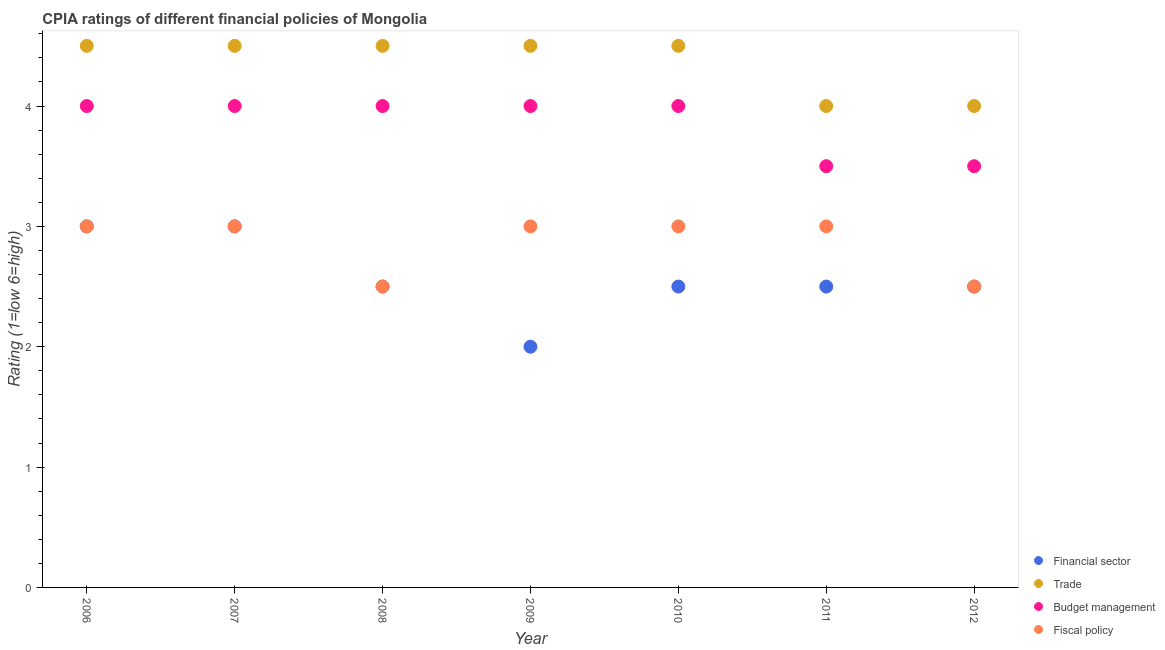Is the number of dotlines equal to the number of legend labels?
Your answer should be compact. Yes. Across all years, what is the maximum cpia rating of trade?
Your answer should be very brief. 4.5. In which year was the cpia rating of trade minimum?
Ensure brevity in your answer.  2011. What is the difference between the cpia rating of budget management in 2007 and that in 2011?
Offer a terse response. 0.5. What is the difference between the cpia rating of fiscal policy in 2006 and the cpia rating of trade in 2009?
Keep it short and to the point. -1.5. What is the average cpia rating of financial sector per year?
Your answer should be compact. 2.57. What is the ratio of the cpia rating of trade in 2007 to that in 2011?
Your answer should be compact. 1.12. In how many years, is the cpia rating of fiscal policy greater than the average cpia rating of fiscal policy taken over all years?
Your answer should be very brief. 5. Is the sum of the cpia rating of budget management in 2009 and 2010 greater than the maximum cpia rating of trade across all years?
Ensure brevity in your answer.  Yes. Is it the case that in every year, the sum of the cpia rating of budget management and cpia rating of financial sector is greater than the sum of cpia rating of trade and cpia rating of fiscal policy?
Offer a very short reply. No. Is it the case that in every year, the sum of the cpia rating of financial sector and cpia rating of trade is greater than the cpia rating of budget management?
Offer a terse response. Yes. Does the cpia rating of trade monotonically increase over the years?
Your answer should be compact. No. Is the cpia rating of budget management strictly greater than the cpia rating of financial sector over the years?
Ensure brevity in your answer.  Yes. Is the cpia rating of trade strictly less than the cpia rating of budget management over the years?
Your answer should be very brief. No. Does the graph contain any zero values?
Keep it short and to the point. No. Does the graph contain grids?
Keep it short and to the point. No. How many legend labels are there?
Offer a very short reply. 4. What is the title of the graph?
Your response must be concise. CPIA ratings of different financial policies of Mongolia. What is the label or title of the X-axis?
Your answer should be very brief. Year. What is the label or title of the Y-axis?
Provide a succinct answer. Rating (1=low 6=high). What is the Rating (1=low 6=high) in Trade in 2006?
Provide a short and direct response. 4.5. What is the Rating (1=low 6=high) of Budget management in 2006?
Offer a terse response. 4. What is the Rating (1=low 6=high) in Budget management in 2007?
Make the answer very short. 4. What is the Rating (1=low 6=high) of Budget management in 2008?
Offer a terse response. 4. What is the Rating (1=low 6=high) in Fiscal policy in 2008?
Your response must be concise. 2.5. What is the Rating (1=low 6=high) of Financial sector in 2009?
Your answer should be very brief. 2. What is the Rating (1=low 6=high) in Trade in 2010?
Your answer should be very brief. 4.5. What is the Rating (1=low 6=high) of Budget management in 2010?
Provide a succinct answer. 4. What is the Rating (1=low 6=high) in Fiscal policy in 2010?
Your response must be concise. 3. What is the Rating (1=low 6=high) of Financial sector in 2011?
Offer a terse response. 2.5. What is the Rating (1=low 6=high) in Budget management in 2012?
Offer a very short reply. 3.5. Across all years, what is the maximum Rating (1=low 6=high) of Financial sector?
Provide a short and direct response. 3. Across all years, what is the maximum Rating (1=low 6=high) in Trade?
Your answer should be compact. 4.5. Across all years, what is the maximum Rating (1=low 6=high) in Budget management?
Your answer should be very brief. 4. Across all years, what is the maximum Rating (1=low 6=high) of Fiscal policy?
Offer a terse response. 3. Across all years, what is the minimum Rating (1=low 6=high) in Financial sector?
Provide a succinct answer. 2. Across all years, what is the minimum Rating (1=low 6=high) in Trade?
Provide a short and direct response. 4. Across all years, what is the minimum Rating (1=low 6=high) in Fiscal policy?
Give a very brief answer. 2.5. What is the total Rating (1=low 6=high) in Financial sector in the graph?
Your answer should be very brief. 18. What is the total Rating (1=low 6=high) of Trade in the graph?
Make the answer very short. 30.5. What is the total Rating (1=low 6=high) in Fiscal policy in the graph?
Offer a very short reply. 20. What is the difference between the Rating (1=low 6=high) of Trade in 2006 and that in 2007?
Provide a short and direct response. 0. What is the difference between the Rating (1=low 6=high) in Budget management in 2006 and that in 2007?
Provide a succinct answer. 0. What is the difference between the Rating (1=low 6=high) in Budget management in 2006 and that in 2008?
Your answer should be compact. 0. What is the difference between the Rating (1=low 6=high) of Trade in 2006 and that in 2009?
Give a very brief answer. 0. What is the difference between the Rating (1=low 6=high) of Fiscal policy in 2006 and that in 2009?
Ensure brevity in your answer.  0. What is the difference between the Rating (1=low 6=high) in Budget management in 2006 and that in 2010?
Give a very brief answer. 0. What is the difference between the Rating (1=low 6=high) of Financial sector in 2006 and that in 2011?
Provide a succinct answer. 0.5. What is the difference between the Rating (1=low 6=high) of Budget management in 2006 and that in 2011?
Give a very brief answer. 0.5. What is the difference between the Rating (1=low 6=high) of Financial sector in 2006 and that in 2012?
Your response must be concise. 0.5. What is the difference between the Rating (1=low 6=high) of Trade in 2006 and that in 2012?
Offer a very short reply. 0.5. What is the difference between the Rating (1=low 6=high) of Budget management in 2006 and that in 2012?
Offer a terse response. 0.5. What is the difference between the Rating (1=low 6=high) in Trade in 2007 and that in 2008?
Provide a succinct answer. 0. What is the difference between the Rating (1=low 6=high) of Financial sector in 2007 and that in 2009?
Ensure brevity in your answer.  1. What is the difference between the Rating (1=low 6=high) of Trade in 2007 and that in 2009?
Keep it short and to the point. 0. What is the difference between the Rating (1=low 6=high) in Fiscal policy in 2007 and that in 2009?
Provide a short and direct response. 0. What is the difference between the Rating (1=low 6=high) of Financial sector in 2007 and that in 2010?
Your answer should be very brief. 0.5. What is the difference between the Rating (1=low 6=high) in Fiscal policy in 2007 and that in 2010?
Ensure brevity in your answer.  0. What is the difference between the Rating (1=low 6=high) of Budget management in 2007 and that in 2011?
Keep it short and to the point. 0.5. What is the difference between the Rating (1=low 6=high) in Fiscal policy in 2007 and that in 2011?
Your response must be concise. 0. What is the difference between the Rating (1=low 6=high) in Financial sector in 2007 and that in 2012?
Your response must be concise. 0.5. What is the difference between the Rating (1=low 6=high) in Trade in 2007 and that in 2012?
Your answer should be compact. 0.5. What is the difference between the Rating (1=low 6=high) of Fiscal policy in 2007 and that in 2012?
Provide a succinct answer. 0.5. What is the difference between the Rating (1=low 6=high) of Budget management in 2008 and that in 2010?
Provide a succinct answer. 0. What is the difference between the Rating (1=low 6=high) of Fiscal policy in 2008 and that in 2010?
Your answer should be compact. -0.5. What is the difference between the Rating (1=low 6=high) in Trade in 2008 and that in 2011?
Provide a short and direct response. 0.5. What is the difference between the Rating (1=low 6=high) of Fiscal policy in 2008 and that in 2011?
Your answer should be compact. -0.5. What is the difference between the Rating (1=low 6=high) in Financial sector in 2008 and that in 2012?
Your answer should be compact. 0. What is the difference between the Rating (1=low 6=high) of Trade in 2008 and that in 2012?
Your response must be concise. 0.5. What is the difference between the Rating (1=low 6=high) of Budget management in 2008 and that in 2012?
Ensure brevity in your answer.  0.5. What is the difference between the Rating (1=low 6=high) of Fiscal policy in 2009 and that in 2011?
Your answer should be very brief. 0. What is the difference between the Rating (1=low 6=high) in Trade in 2009 and that in 2012?
Keep it short and to the point. 0.5. What is the difference between the Rating (1=low 6=high) of Budget management in 2009 and that in 2012?
Ensure brevity in your answer.  0.5. What is the difference between the Rating (1=low 6=high) in Financial sector in 2010 and that in 2011?
Offer a terse response. 0. What is the difference between the Rating (1=low 6=high) of Trade in 2010 and that in 2011?
Provide a succinct answer. 0.5. What is the difference between the Rating (1=low 6=high) in Fiscal policy in 2010 and that in 2011?
Your answer should be very brief. 0. What is the difference between the Rating (1=low 6=high) in Financial sector in 2010 and that in 2012?
Provide a succinct answer. 0. What is the difference between the Rating (1=low 6=high) of Fiscal policy in 2010 and that in 2012?
Offer a terse response. 0.5. What is the difference between the Rating (1=low 6=high) of Budget management in 2011 and that in 2012?
Keep it short and to the point. 0. What is the difference between the Rating (1=low 6=high) in Financial sector in 2006 and the Rating (1=low 6=high) in Budget management in 2007?
Offer a terse response. -1. What is the difference between the Rating (1=low 6=high) of Financial sector in 2006 and the Rating (1=low 6=high) of Fiscal policy in 2007?
Give a very brief answer. 0. What is the difference between the Rating (1=low 6=high) of Trade in 2006 and the Rating (1=low 6=high) of Budget management in 2007?
Offer a very short reply. 0.5. What is the difference between the Rating (1=low 6=high) of Budget management in 2006 and the Rating (1=low 6=high) of Fiscal policy in 2007?
Offer a terse response. 1. What is the difference between the Rating (1=low 6=high) of Financial sector in 2006 and the Rating (1=low 6=high) of Budget management in 2008?
Offer a very short reply. -1. What is the difference between the Rating (1=low 6=high) of Financial sector in 2006 and the Rating (1=low 6=high) of Fiscal policy in 2008?
Keep it short and to the point. 0.5. What is the difference between the Rating (1=low 6=high) in Trade in 2006 and the Rating (1=low 6=high) in Budget management in 2008?
Offer a terse response. 0.5. What is the difference between the Rating (1=low 6=high) in Trade in 2006 and the Rating (1=low 6=high) in Fiscal policy in 2008?
Your response must be concise. 2. What is the difference between the Rating (1=low 6=high) of Financial sector in 2006 and the Rating (1=low 6=high) of Trade in 2009?
Offer a terse response. -1.5. What is the difference between the Rating (1=low 6=high) of Trade in 2006 and the Rating (1=low 6=high) of Fiscal policy in 2009?
Offer a very short reply. 1.5. What is the difference between the Rating (1=low 6=high) of Trade in 2006 and the Rating (1=low 6=high) of Fiscal policy in 2010?
Keep it short and to the point. 1.5. What is the difference between the Rating (1=low 6=high) of Budget management in 2006 and the Rating (1=low 6=high) of Fiscal policy in 2010?
Provide a succinct answer. 1. What is the difference between the Rating (1=low 6=high) of Financial sector in 2006 and the Rating (1=low 6=high) of Trade in 2011?
Keep it short and to the point. -1. What is the difference between the Rating (1=low 6=high) in Budget management in 2006 and the Rating (1=low 6=high) in Fiscal policy in 2011?
Keep it short and to the point. 1. What is the difference between the Rating (1=low 6=high) in Financial sector in 2006 and the Rating (1=low 6=high) in Trade in 2012?
Ensure brevity in your answer.  -1. What is the difference between the Rating (1=low 6=high) in Trade in 2006 and the Rating (1=low 6=high) in Fiscal policy in 2012?
Your answer should be very brief. 2. What is the difference between the Rating (1=low 6=high) of Budget management in 2006 and the Rating (1=low 6=high) of Fiscal policy in 2012?
Offer a terse response. 1.5. What is the difference between the Rating (1=low 6=high) in Financial sector in 2007 and the Rating (1=low 6=high) in Trade in 2008?
Make the answer very short. -1.5. What is the difference between the Rating (1=low 6=high) in Financial sector in 2007 and the Rating (1=low 6=high) in Budget management in 2008?
Offer a terse response. -1. What is the difference between the Rating (1=low 6=high) in Trade in 2007 and the Rating (1=low 6=high) in Budget management in 2008?
Your answer should be compact. 0.5. What is the difference between the Rating (1=low 6=high) of Trade in 2007 and the Rating (1=low 6=high) of Fiscal policy in 2008?
Your answer should be compact. 2. What is the difference between the Rating (1=low 6=high) in Financial sector in 2007 and the Rating (1=low 6=high) in Trade in 2009?
Your answer should be compact. -1.5. What is the difference between the Rating (1=low 6=high) in Financial sector in 2007 and the Rating (1=low 6=high) in Budget management in 2009?
Give a very brief answer. -1. What is the difference between the Rating (1=low 6=high) in Financial sector in 2007 and the Rating (1=low 6=high) in Fiscal policy in 2009?
Your response must be concise. 0. What is the difference between the Rating (1=low 6=high) of Trade in 2007 and the Rating (1=low 6=high) of Fiscal policy in 2009?
Your answer should be compact. 1.5. What is the difference between the Rating (1=low 6=high) of Budget management in 2007 and the Rating (1=low 6=high) of Fiscal policy in 2009?
Your answer should be compact. 1. What is the difference between the Rating (1=low 6=high) of Financial sector in 2007 and the Rating (1=low 6=high) of Trade in 2010?
Offer a very short reply. -1.5. What is the difference between the Rating (1=low 6=high) in Financial sector in 2007 and the Rating (1=low 6=high) in Budget management in 2010?
Provide a succinct answer. -1. What is the difference between the Rating (1=low 6=high) in Financial sector in 2007 and the Rating (1=low 6=high) in Fiscal policy in 2010?
Keep it short and to the point. 0. What is the difference between the Rating (1=low 6=high) of Trade in 2007 and the Rating (1=low 6=high) of Budget management in 2010?
Offer a terse response. 0.5. What is the difference between the Rating (1=low 6=high) in Financial sector in 2007 and the Rating (1=low 6=high) in Trade in 2011?
Offer a very short reply. -1. What is the difference between the Rating (1=low 6=high) of Financial sector in 2007 and the Rating (1=low 6=high) of Budget management in 2011?
Give a very brief answer. -0.5. What is the difference between the Rating (1=low 6=high) of Financial sector in 2007 and the Rating (1=low 6=high) of Fiscal policy in 2011?
Your response must be concise. 0. What is the difference between the Rating (1=low 6=high) in Trade in 2007 and the Rating (1=low 6=high) in Budget management in 2011?
Ensure brevity in your answer.  1. What is the difference between the Rating (1=low 6=high) of Trade in 2007 and the Rating (1=low 6=high) of Fiscal policy in 2011?
Make the answer very short. 1.5. What is the difference between the Rating (1=low 6=high) in Financial sector in 2007 and the Rating (1=low 6=high) in Budget management in 2012?
Give a very brief answer. -0.5. What is the difference between the Rating (1=low 6=high) of Financial sector in 2007 and the Rating (1=low 6=high) of Fiscal policy in 2012?
Your answer should be compact. 0.5. What is the difference between the Rating (1=low 6=high) of Trade in 2007 and the Rating (1=low 6=high) of Budget management in 2012?
Your answer should be compact. 1. What is the difference between the Rating (1=low 6=high) in Trade in 2007 and the Rating (1=low 6=high) in Fiscal policy in 2012?
Offer a terse response. 2. What is the difference between the Rating (1=low 6=high) of Financial sector in 2008 and the Rating (1=low 6=high) of Budget management in 2009?
Provide a succinct answer. -1.5. What is the difference between the Rating (1=low 6=high) in Trade in 2008 and the Rating (1=low 6=high) in Fiscal policy in 2009?
Provide a short and direct response. 1.5. What is the difference between the Rating (1=low 6=high) of Financial sector in 2008 and the Rating (1=low 6=high) of Trade in 2010?
Your answer should be very brief. -2. What is the difference between the Rating (1=low 6=high) of Financial sector in 2008 and the Rating (1=low 6=high) of Fiscal policy in 2010?
Keep it short and to the point. -0.5. What is the difference between the Rating (1=low 6=high) of Trade in 2008 and the Rating (1=low 6=high) of Fiscal policy in 2010?
Give a very brief answer. 1.5. What is the difference between the Rating (1=low 6=high) in Financial sector in 2008 and the Rating (1=low 6=high) in Trade in 2011?
Provide a short and direct response. -1.5. What is the difference between the Rating (1=low 6=high) of Financial sector in 2008 and the Rating (1=low 6=high) of Fiscal policy in 2011?
Ensure brevity in your answer.  -0.5. What is the difference between the Rating (1=low 6=high) of Trade in 2008 and the Rating (1=low 6=high) of Fiscal policy in 2011?
Keep it short and to the point. 1.5. What is the difference between the Rating (1=low 6=high) in Budget management in 2008 and the Rating (1=low 6=high) in Fiscal policy in 2011?
Your answer should be compact. 1. What is the difference between the Rating (1=low 6=high) of Financial sector in 2008 and the Rating (1=low 6=high) of Budget management in 2012?
Provide a succinct answer. -1. What is the difference between the Rating (1=low 6=high) in Trade in 2008 and the Rating (1=low 6=high) in Budget management in 2012?
Your response must be concise. 1. What is the difference between the Rating (1=low 6=high) in Budget management in 2008 and the Rating (1=low 6=high) in Fiscal policy in 2012?
Provide a succinct answer. 1.5. What is the difference between the Rating (1=low 6=high) in Financial sector in 2009 and the Rating (1=low 6=high) in Budget management in 2010?
Your answer should be compact. -2. What is the difference between the Rating (1=low 6=high) of Trade in 2009 and the Rating (1=low 6=high) of Budget management in 2010?
Your response must be concise. 0.5. What is the difference between the Rating (1=low 6=high) of Trade in 2009 and the Rating (1=low 6=high) of Budget management in 2011?
Your response must be concise. 1. What is the difference between the Rating (1=low 6=high) of Financial sector in 2009 and the Rating (1=low 6=high) of Trade in 2012?
Keep it short and to the point. -2. What is the difference between the Rating (1=low 6=high) in Financial sector in 2009 and the Rating (1=low 6=high) in Budget management in 2012?
Make the answer very short. -1.5. What is the difference between the Rating (1=low 6=high) in Trade in 2009 and the Rating (1=low 6=high) in Budget management in 2012?
Make the answer very short. 1. What is the difference between the Rating (1=low 6=high) in Trade in 2009 and the Rating (1=low 6=high) in Fiscal policy in 2012?
Your answer should be very brief. 2. What is the difference between the Rating (1=low 6=high) of Budget management in 2009 and the Rating (1=low 6=high) of Fiscal policy in 2012?
Offer a very short reply. 1.5. What is the difference between the Rating (1=low 6=high) in Financial sector in 2010 and the Rating (1=low 6=high) in Budget management in 2011?
Offer a very short reply. -1. What is the difference between the Rating (1=low 6=high) in Financial sector in 2010 and the Rating (1=low 6=high) in Fiscal policy in 2011?
Make the answer very short. -0.5. What is the difference between the Rating (1=low 6=high) in Trade in 2010 and the Rating (1=low 6=high) in Budget management in 2011?
Keep it short and to the point. 1. What is the difference between the Rating (1=low 6=high) of Financial sector in 2010 and the Rating (1=low 6=high) of Fiscal policy in 2012?
Provide a succinct answer. 0. What is the difference between the Rating (1=low 6=high) in Trade in 2010 and the Rating (1=low 6=high) in Budget management in 2012?
Your response must be concise. 1. What is the difference between the Rating (1=low 6=high) in Trade in 2010 and the Rating (1=low 6=high) in Fiscal policy in 2012?
Give a very brief answer. 2. What is the difference between the Rating (1=low 6=high) of Trade in 2011 and the Rating (1=low 6=high) of Budget management in 2012?
Offer a very short reply. 0.5. What is the difference between the Rating (1=low 6=high) in Trade in 2011 and the Rating (1=low 6=high) in Fiscal policy in 2012?
Your response must be concise. 1.5. What is the average Rating (1=low 6=high) in Financial sector per year?
Keep it short and to the point. 2.57. What is the average Rating (1=low 6=high) of Trade per year?
Offer a terse response. 4.36. What is the average Rating (1=low 6=high) in Budget management per year?
Your answer should be very brief. 3.86. What is the average Rating (1=low 6=high) in Fiscal policy per year?
Offer a very short reply. 2.86. In the year 2006, what is the difference between the Rating (1=low 6=high) of Financial sector and Rating (1=low 6=high) of Trade?
Offer a terse response. -1.5. In the year 2006, what is the difference between the Rating (1=low 6=high) in Financial sector and Rating (1=low 6=high) in Budget management?
Offer a very short reply. -1. In the year 2007, what is the difference between the Rating (1=low 6=high) of Financial sector and Rating (1=low 6=high) of Trade?
Provide a succinct answer. -1.5. In the year 2007, what is the difference between the Rating (1=low 6=high) in Financial sector and Rating (1=low 6=high) in Budget management?
Your response must be concise. -1. In the year 2007, what is the difference between the Rating (1=low 6=high) in Trade and Rating (1=low 6=high) in Budget management?
Your answer should be compact. 0.5. In the year 2007, what is the difference between the Rating (1=low 6=high) of Trade and Rating (1=low 6=high) of Fiscal policy?
Your answer should be compact. 1.5. In the year 2007, what is the difference between the Rating (1=low 6=high) of Budget management and Rating (1=low 6=high) of Fiscal policy?
Ensure brevity in your answer.  1. In the year 2008, what is the difference between the Rating (1=low 6=high) of Financial sector and Rating (1=low 6=high) of Trade?
Provide a short and direct response. -2. In the year 2008, what is the difference between the Rating (1=low 6=high) in Financial sector and Rating (1=low 6=high) in Budget management?
Your answer should be very brief. -1.5. In the year 2008, what is the difference between the Rating (1=low 6=high) of Financial sector and Rating (1=low 6=high) of Fiscal policy?
Your answer should be compact. 0. In the year 2008, what is the difference between the Rating (1=low 6=high) of Trade and Rating (1=low 6=high) of Budget management?
Make the answer very short. 0.5. In the year 2008, what is the difference between the Rating (1=low 6=high) of Trade and Rating (1=low 6=high) of Fiscal policy?
Your response must be concise. 2. In the year 2009, what is the difference between the Rating (1=low 6=high) in Financial sector and Rating (1=low 6=high) in Fiscal policy?
Ensure brevity in your answer.  -1. In the year 2009, what is the difference between the Rating (1=low 6=high) of Trade and Rating (1=low 6=high) of Budget management?
Make the answer very short. 0.5. In the year 2009, what is the difference between the Rating (1=low 6=high) in Budget management and Rating (1=low 6=high) in Fiscal policy?
Offer a terse response. 1. In the year 2010, what is the difference between the Rating (1=low 6=high) of Financial sector and Rating (1=low 6=high) of Fiscal policy?
Keep it short and to the point. -0.5. In the year 2012, what is the difference between the Rating (1=low 6=high) in Financial sector and Rating (1=low 6=high) in Budget management?
Ensure brevity in your answer.  -1. In the year 2012, what is the difference between the Rating (1=low 6=high) of Financial sector and Rating (1=low 6=high) of Fiscal policy?
Offer a terse response. 0. What is the ratio of the Rating (1=low 6=high) in Fiscal policy in 2006 to that in 2007?
Your answer should be very brief. 1. What is the ratio of the Rating (1=low 6=high) of Financial sector in 2006 to that in 2008?
Ensure brevity in your answer.  1.2. What is the ratio of the Rating (1=low 6=high) in Trade in 2006 to that in 2008?
Your answer should be very brief. 1. What is the ratio of the Rating (1=low 6=high) of Budget management in 2006 to that in 2008?
Your response must be concise. 1. What is the ratio of the Rating (1=low 6=high) in Fiscal policy in 2006 to that in 2008?
Your response must be concise. 1.2. What is the ratio of the Rating (1=low 6=high) of Financial sector in 2006 to that in 2009?
Ensure brevity in your answer.  1.5. What is the ratio of the Rating (1=low 6=high) of Financial sector in 2006 to that in 2010?
Provide a short and direct response. 1.2. What is the ratio of the Rating (1=low 6=high) in Trade in 2006 to that in 2010?
Your answer should be very brief. 1. What is the ratio of the Rating (1=low 6=high) of Budget management in 2006 to that in 2010?
Keep it short and to the point. 1. What is the ratio of the Rating (1=low 6=high) of Fiscal policy in 2006 to that in 2010?
Provide a short and direct response. 1. What is the ratio of the Rating (1=low 6=high) of Financial sector in 2006 to that in 2011?
Offer a very short reply. 1.2. What is the ratio of the Rating (1=low 6=high) of Budget management in 2006 to that in 2011?
Offer a terse response. 1.14. What is the ratio of the Rating (1=low 6=high) of Financial sector in 2006 to that in 2012?
Give a very brief answer. 1.2. What is the ratio of the Rating (1=low 6=high) in Trade in 2006 to that in 2012?
Your answer should be very brief. 1.12. What is the ratio of the Rating (1=low 6=high) of Fiscal policy in 2006 to that in 2012?
Provide a succinct answer. 1.2. What is the ratio of the Rating (1=low 6=high) in Trade in 2007 to that in 2008?
Offer a terse response. 1. What is the ratio of the Rating (1=low 6=high) in Budget management in 2007 to that in 2008?
Offer a very short reply. 1. What is the ratio of the Rating (1=low 6=high) of Fiscal policy in 2007 to that in 2008?
Provide a succinct answer. 1.2. What is the ratio of the Rating (1=low 6=high) in Trade in 2007 to that in 2009?
Provide a succinct answer. 1. What is the ratio of the Rating (1=low 6=high) of Budget management in 2007 to that in 2009?
Provide a succinct answer. 1. What is the ratio of the Rating (1=low 6=high) of Fiscal policy in 2007 to that in 2009?
Your answer should be compact. 1. What is the ratio of the Rating (1=low 6=high) in Fiscal policy in 2007 to that in 2010?
Offer a terse response. 1. What is the ratio of the Rating (1=low 6=high) of Trade in 2007 to that in 2011?
Offer a very short reply. 1.12. What is the ratio of the Rating (1=low 6=high) of Budget management in 2007 to that in 2011?
Your answer should be very brief. 1.14. What is the ratio of the Rating (1=low 6=high) of Fiscal policy in 2007 to that in 2011?
Offer a terse response. 1. What is the ratio of the Rating (1=low 6=high) of Financial sector in 2007 to that in 2012?
Keep it short and to the point. 1.2. What is the ratio of the Rating (1=low 6=high) in Trade in 2007 to that in 2012?
Keep it short and to the point. 1.12. What is the ratio of the Rating (1=low 6=high) of Budget management in 2008 to that in 2009?
Provide a succinct answer. 1. What is the ratio of the Rating (1=low 6=high) in Trade in 2008 to that in 2010?
Keep it short and to the point. 1. What is the ratio of the Rating (1=low 6=high) of Fiscal policy in 2008 to that in 2010?
Keep it short and to the point. 0.83. What is the ratio of the Rating (1=low 6=high) in Financial sector in 2008 to that in 2011?
Keep it short and to the point. 1. What is the ratio of the Rating (1=low 6=high) of Trade in 2008 to that in 2011?
Ensure brevity in your answer.  1.12. What is the ratio of the Rating (1=low 6=high) in Budget management in 2008 to that in 2011?
Make the answer very short. 1.14. What is the ratio of the Rating (1=low 6=high) in Financial sector in 2008 to that in 2012?
Offer a terse response. 1. What is the ratio of the Rating (1=low 6=high) in Trade in 2008 to that in 2012?
Your answer should be very brief. 1.12. What is the ratio of the Rating (1=low 6=high) in Trade in 2009 to that in 2010?
Provide a short and direct response. 1. What is the ratio of the Rating (1=low 6=high) of Financial sector in 2009 to that in 2011?
Provide a succinct answer. 0.8. What is the ratio of the Rating (1=low 6=high) of Budget management in 2009 to that in 2011?
Provide a succinct answer. 1.14. What is the ratio of the Rating (1=low 6=high) in Fiscal policy in 2009 to that in 2011?
Your response must be concise. 1. What is the ratio of the Rating (1=low 6=high) in Trade in 2009 to that in 2012?
Provide a succinct answer. 1.12. What is the ratio of the Rating (1=low 6=high) in Budget management in 2009 to that in 2012?
Provide a succinct answer. 1.14. What is the ratio of the Rating (1=low 6=high) of Fiscal policy in 2009 to that in 2012?
Your answer should be compact. 1.2. What is the ratio of the Rating (1=low 6=high) in Budget management in 2010 to that in 2011?
Keep it short and to the point. 1.14. What is the ratio of the Rating (1=low 6=high) in Fiscal policy in 2010 to that in 2011?
Make the answer very short. 1. What is the ratio of the Rating (1=low 6=high) in Financial sector in 2010 to that in 2012?
Make the answer very short. 1. What is the ratio of the Rating (1=low 6=high) of Trade in 2010 to that in 2012?
Your answer should be compact. 1.12. What is the ratio of the Rating (1=low 6=high) in Financial sector in 2011 to that in 2012?
Give a very brief answer. 1. What is the ratio of the Rating (1=low 6=high) in Trade in 2011 to that in 2012?
Offer a terse response. 1. What is the ratio of the Rating (1=low 6=high) in Budget management in 2011 to that in 2012?
Keep it short and to the point. 1. What is the difference between the highest and the second highest Rating (1=low 6=high) in Trade?
Provide a short and direct response. 0. What is the difference between the highest and the second highest Rating (1=low 6=high) in Budget management?
Offer a very short reply. 0. What is the difference between the highest and the lowest Rating (1=low 6=high) of Financial sector?
Ensure brevity in your answer.  1. What is the difference between the highest and the lowest Rating (1=low 6=high) in Trade?
Give a very brief answer. 0.5. What is the difference between the highest and the lowest Rating (1=low 6=high) in Fiscal policy?
Offer a very short reply. 0.5. 